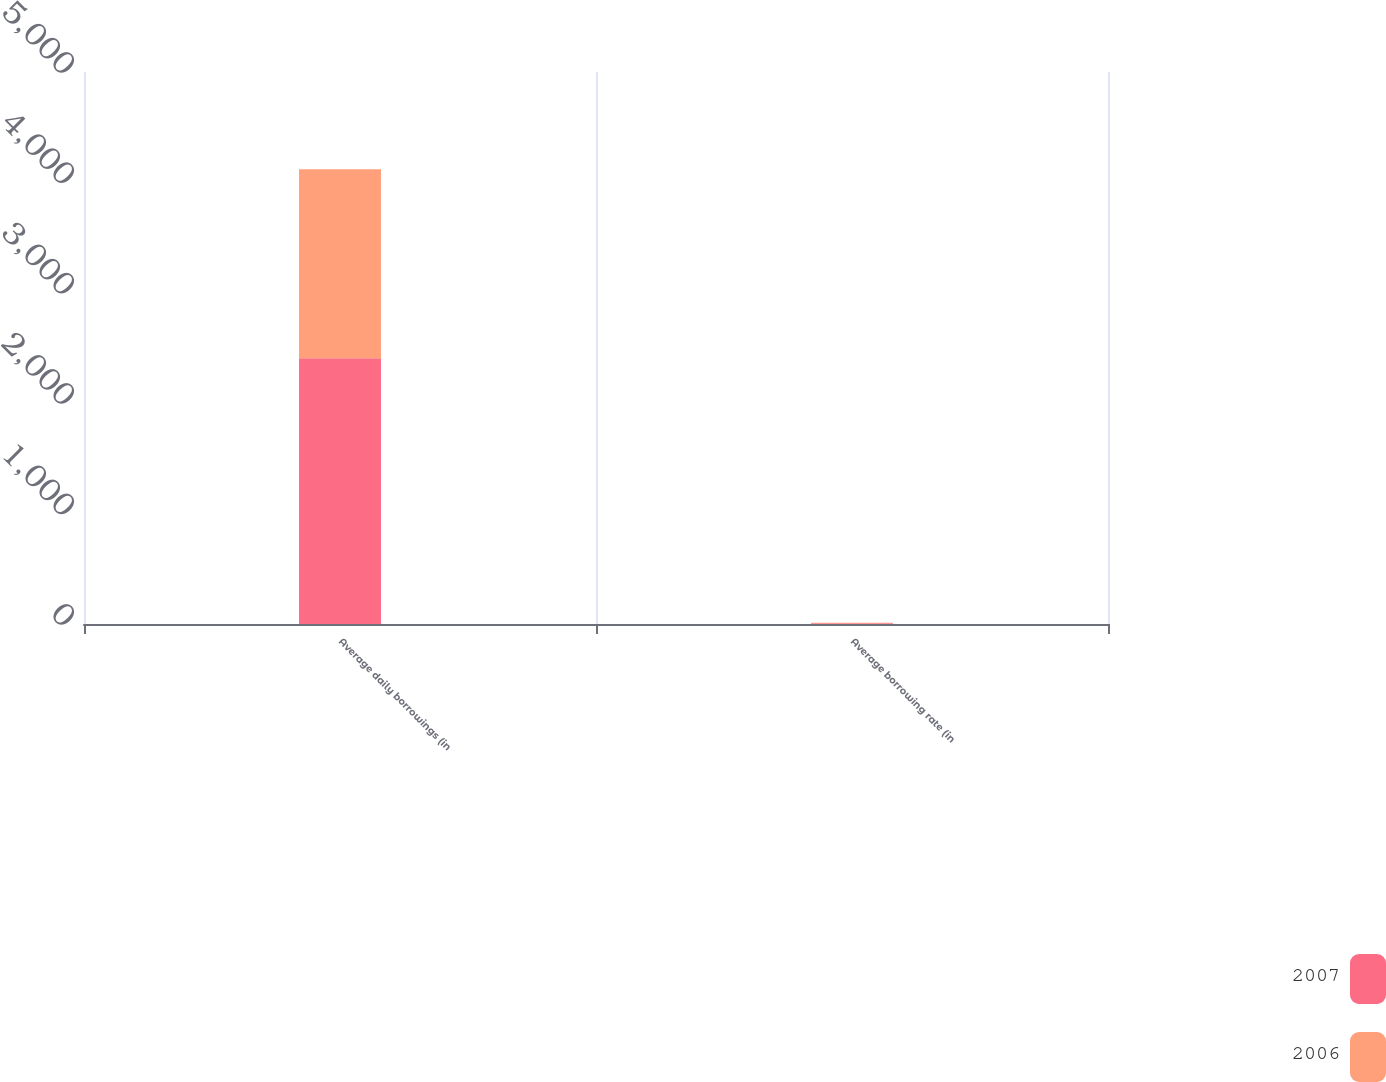Convert chart. <chart><loc_0><loc_0><loc_500><loc_500><stacked_bar_chart><ecel><fcel>Average daily borrowings (in<fcel>Average borrowing rate (in<nl><fcel>2007<fcel>2408<fcel>6.2<nl><fcel>2006<fcel>1711<fcel>5.9<nl></chart> 